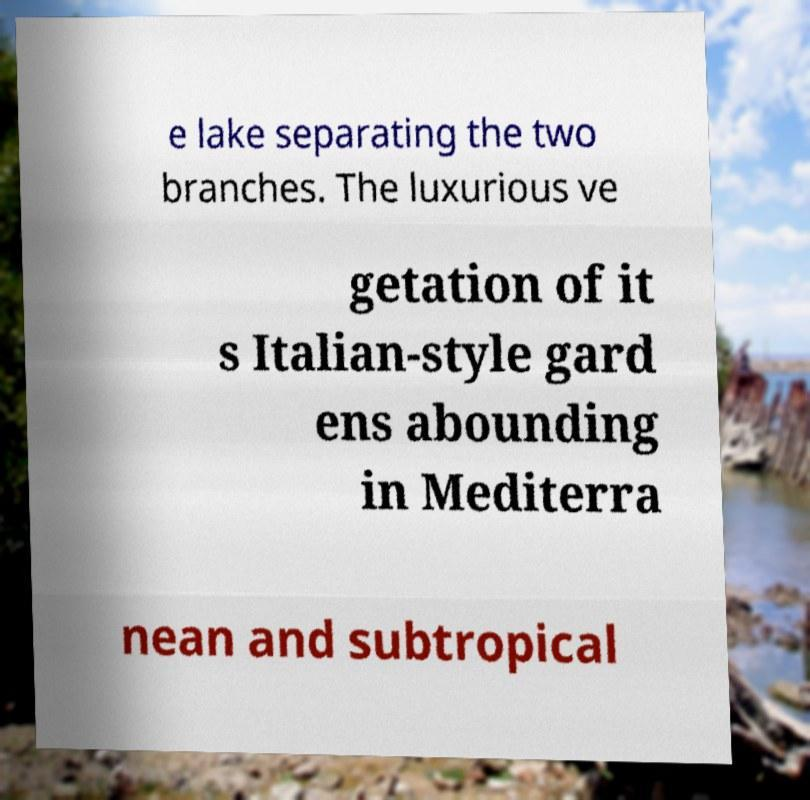For documentation purposes, I need the text within this image transcribed. Could you provide that? e lake separating the two branches. The luxurious ve getation of it s Italian-style gard ens abounding in Mediterra nean and subtropical 